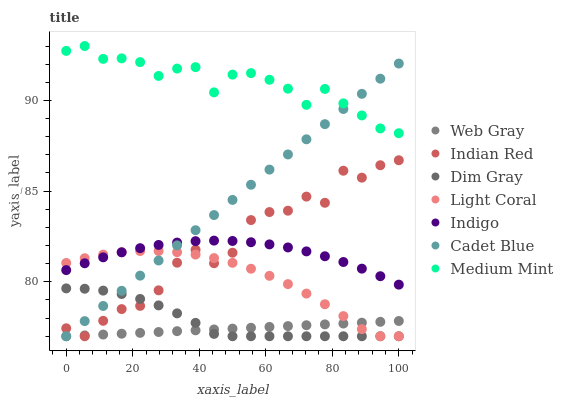Does Web Gray have the minimum area under the curve?
Answer yes or no. Yes. Does Medium Mint have the maximum area under the curve?
Answer yes or no. Yes. Does Cadet Blue have the minimum area under the curve?
Answer yes or no. No. Does Cadet Blue have the maximum area under the curve?
Answer yes or no. No. Is Web Gray the smoothest?
Answer yes or no. Yes. Is Indian Red the roughest?
Answer yes or no. Yes. Is Cadet Blue the smoothest?
Answer yes or no. No. Is Cadet Blue the roughest?
Answer yes or no. No. Does Cadet Blue have the lowest value?
Answer yes or no. Yes. Does Indigo have the lowest value?
Answer yes or no. No. Does Medium Mint have the highest value?
Answer yes or no. Yes. Does Cadet Blue have the highest value?
Answer yes or no. No. Is Dim Gray less than Medium Mint?
Answer yes or no. Yes. Is Medium Mint greater than Dim Gray?
Answer yes or no. Yes. Does Medium Mint intersect Cadet Blue?
Answer yes or no. Yes. Is Medium Mint less than Cadet Blue?
Answer yes or no. No. Is Medium Mint greater than Cadet Blue?
Answer yes or no. No. Does Dim Gray intersect Medium Mint?
Answer yes or no. No. 